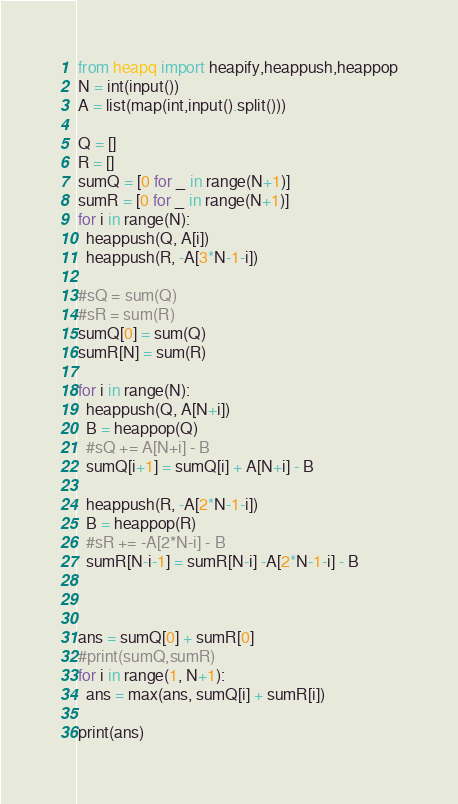Convert code to text. <code><loc_0><loc_0><loc_500><loc_500><_Python_>from heapq import heapify,heappush,heappop
N = int(input())
A = list(map(int,input().split()))

Q = []
R = []
sumQ = [0 for _ in range(N+1)]
sumR = [0 for _ in range(N+1)]
for i in range(N):
  heappush(Q, A[i])
  heappush(R, -A[3*N-1-i])

#sQ = sum(Q)
#sR = sum(R)
sumQ[0] = sum(Q)
sumR[N] = sum(R)

for i in range(N):
  heappush(Q, A[N+i])
  B = heappop(Q)
  #sQ += A[N+i] - B
  sumQ[i+1] = sumQ[i] + A[N+i] - B
  
  heappush(R, -A[2*N-1-i])
  B = heappop(R)
  #sR += -A[2*N-i] - B
  sumR[N-i-1] = sumR[N-i] -A[2*N-1-i] - B
  
  

ans = sumQ[0] + sumR[0]
#print(sumQ,sumR)
for i in range(1, N+1):
  ans = max(ans, sumQ[i] + sumR[i])
  
print(ans)</code> 